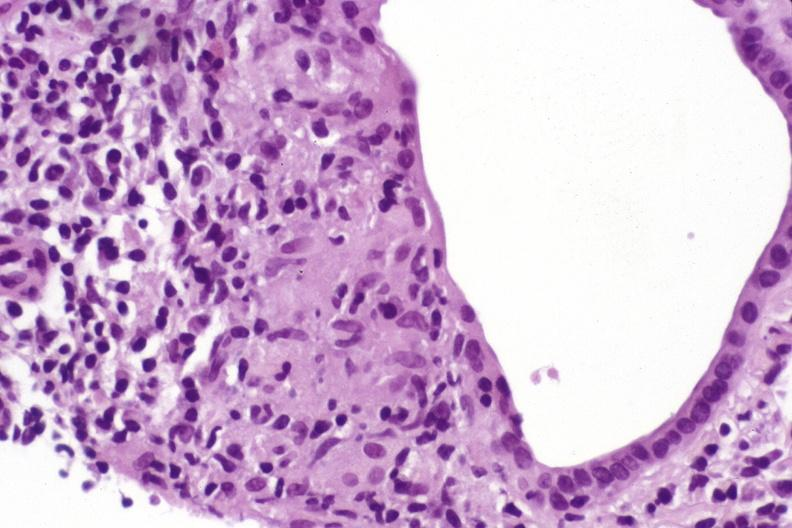s liver present?
Answer the question using a single word or phrase. Yes 